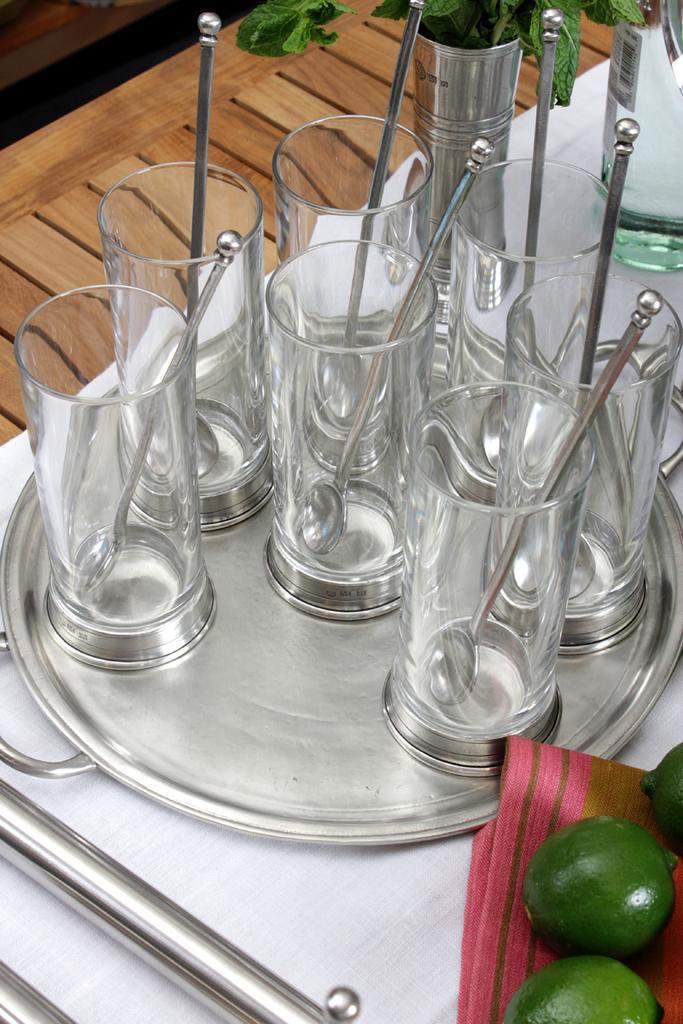How would you summarize this image in a sentence or two? In the foreground of this image, we can see glasses, spoons, platter, white cloth, wooden surface, a bottle and fruits on the cloth. 